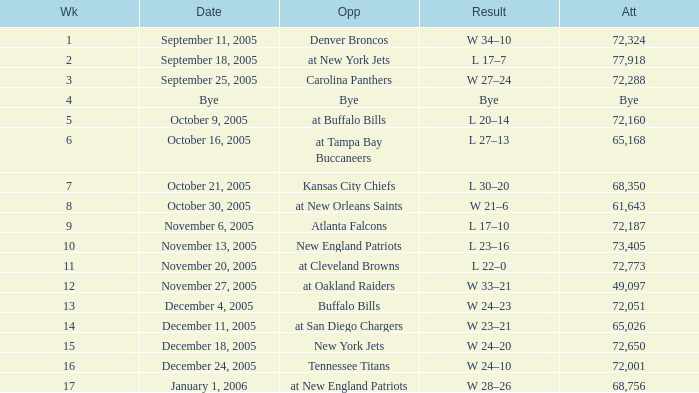In which week was the attendance recorded as 49,097? 12.0. 